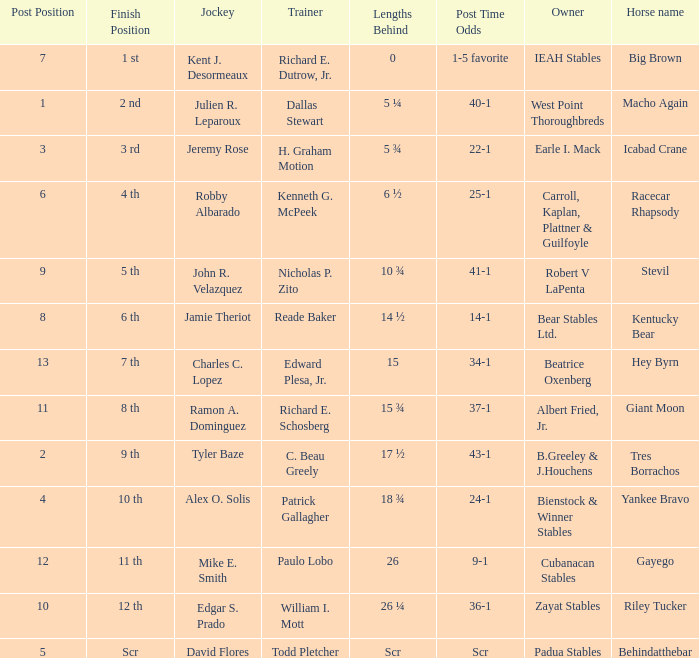Who was the jockey that had post time odds of 34-1? Charles C. Lopez. Would you mind parsing the complete table? {'header': ['Post Position', 'Finish Position', 'Jockey', 'Trainer', 'Lengths Behind', 'Post Time Odds', 'Owner', 'Horse name'], 'rows': [['7', '1 st', 'Kent J. Desormeaux', 'Richard E. Dutrow, Jr.', '0', '1-5 favorite', 'IEAH Stables', 'Big Brown'], ['1', '2 nd', 'Julien R. Leparoux', 'Dallas Stewart', '5 ¼', '40-1', 'West Point Thoroughbreds', 'Macho Again'], ['3', '3 rd', 'Jeremy Rose', 'H. Graham Motion', '5 ¾', '22-1', 'Earle I. Mack', 'Icabad Crane'], ['6', '4 th', 'Robby Albarado', 'Kenneth G. McPeek', '6 ½', '25-1', 'Carroll, Kaplan, Plattner & Guilfoyle', 'Racecar Rhapsody'], ['9', '5 th', 'John R. Velazquez', 'Nicholas P. Zito', '10 ¾', '41-1', 'Robert V LaPenta', 'Stevil'], ['8', '6 th', 'Jamie Theriot', 'Reade Baker', '14 ½', '14-1', 'Bear Stables Ltd.', 'Kentucky Bear'], ['13', '7 th', 'Charles C. Lopez', 'Edward Plesa, Jr.', '15', '34-1', 'Beatrice Oxenberg', 'Hey Byrn'], ['11', '8 th', 'Ramon A. Dominguez', 'Richard E. Schosberg', '15 ¾', '37-1', 'Albert Fried, Jr.', 'Giant Moon'], ['2', '9 th', 'Tyler Baze', 'C. Beau Greely', '17 ½', '43-1', 'B.Greeley & J.Houchens', 'Tres Borrachos'], ['4', '10 th', 'Alex O. Solis', 'Patrick Gallagher', '18 ¾', '24-1', 'Bienstock & Winner Stables', 'Yankee Bravo'], ['12', '11 th', 'Mike E. Smith', 'Paulo Lobo', '26', '9-1', 'Cubanacan Stables', 'Gayego'], ['10', '12 th', 'Edgar S. Prado', 'William I. Mott', '26 ¼', '36-1', 'Zayat Stables', 'Riley Tucker'], ['5', 'Scr', 'David Flores', 'Todd Pletcher', 'Scr', 'Scr', 'Padua Stables', 'Behindatthebar']]} 